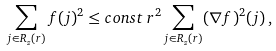<formula> <loc_0><loc_0><loc_500><loc_500>\sum _ { j \in R _ { z } ( r ) } f ( j ) ^ { 2 } \leq c o n s t \, r ^ { 2 } \sum _ { j \in R _ { z } ( r ) } ( \nabla f ) ^ { 2 } ( j ) \, ,</formula> 